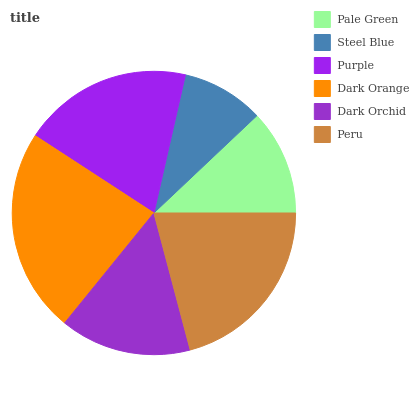Is Steel Blue the minimum?
Answer yes or no. Yes. Is Dark Orange the maximum?
Answer yes or no. Yes. Is Purple the minimum?
Answer yes or no. No. Is Purple the maximum?
Answer yes or no. No. Is Purple greater than Steel Blue?
Answer yes or no. Yes. Is Steel Blue less than Purple?
Answer yes or no. Yes. Is Steel Blue greater than Purple?
Answer yes or no. No. Is Purple less than Steel Blue?
Answer yes or no. No. Is Purple the high median?
Answer yes or no. Yes. Is Dark Orchid the low median?
Answer yes or no. Yes. Is Steel Blue the high median?
Answer yes or no. No. Is Pale Green the low median?
Answer yes or no. No. 